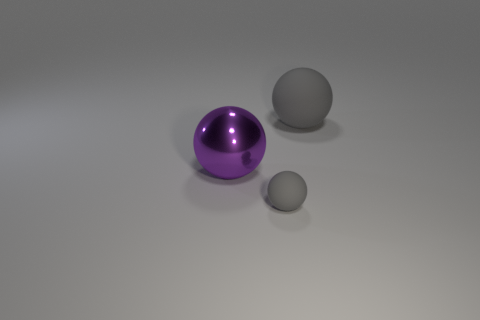Add 3 tiny gray spheres. How many objects exist? 6 Subtract all large yellow things. Subtract all big purple spheres. How many objects are left? 2 Add 1 large purple metal things. How many large purple metal things are left? 2 Add 3 big red spheres. How many big red spheres exist? 3 Subtract 0 yellow balls. How many objects are left? 3 